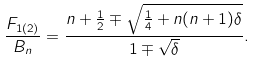Convert formula to latex. <formula><loc_0><loc_0><loc_500><loc_500>\frac { F _ { 1 ( 2 ) } } { B _ { n } } = \frac { n + \frac { 1 } { 2 } \mp \sqrt { \frac { 1 } { 4 } + n ( n + 1 ) \delta } } { 1 \mp \sqrt { \delta } } .</formula> 